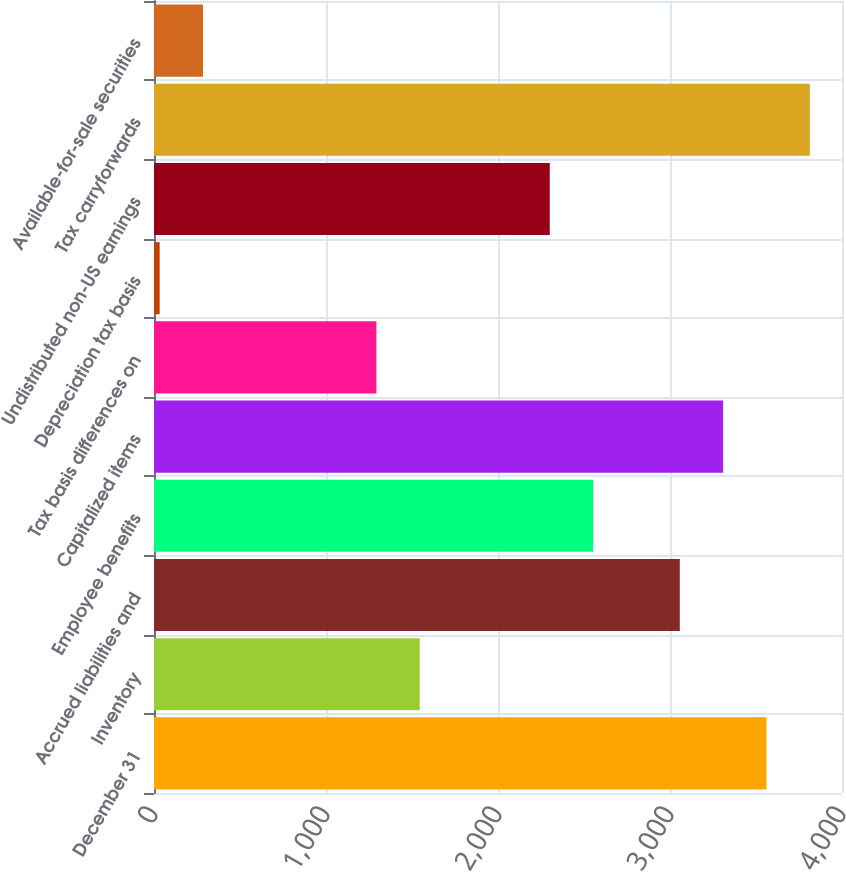Convert chart to OTSL. <chart><loc_0><loc_0><loc_500><loc_500><bar_chart><fcel>December 31<fcel>Inventory<fcel>Accrued liabilities and<fcel>Employee benefits<fcel>Capitalized items<fcel>Tax basis differences on<fcel>Depreciation tax basis<fcel>Undistributed non-US earnings<fcel>Tax carryforwards<fcel>Available-for-sale securities<nl><fcel>3561<fcel>1545<fcel>3057<fcel>2553<fcel>3309<fcel>1293<fcel>33<fcel>2301<fcel>3813<fcel>285<nl></chart> 